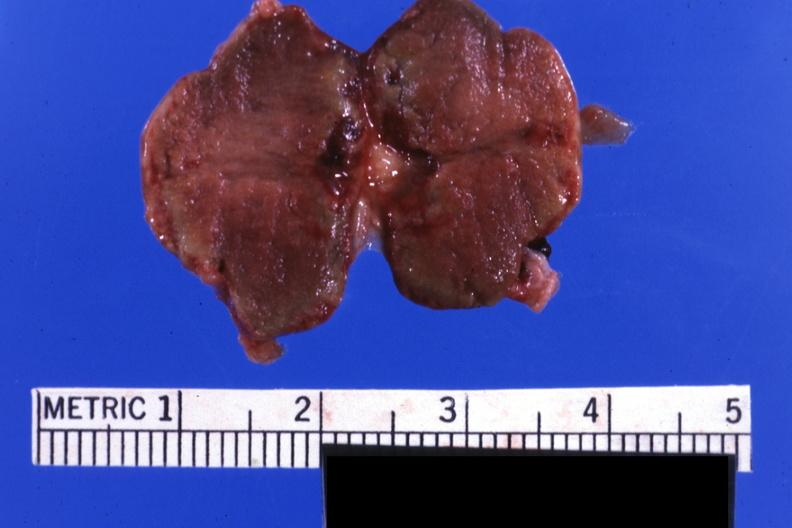does this image show fixed tissue but good color gland not recognizable as such?
Answer the question using a single word or phrase. Yes 